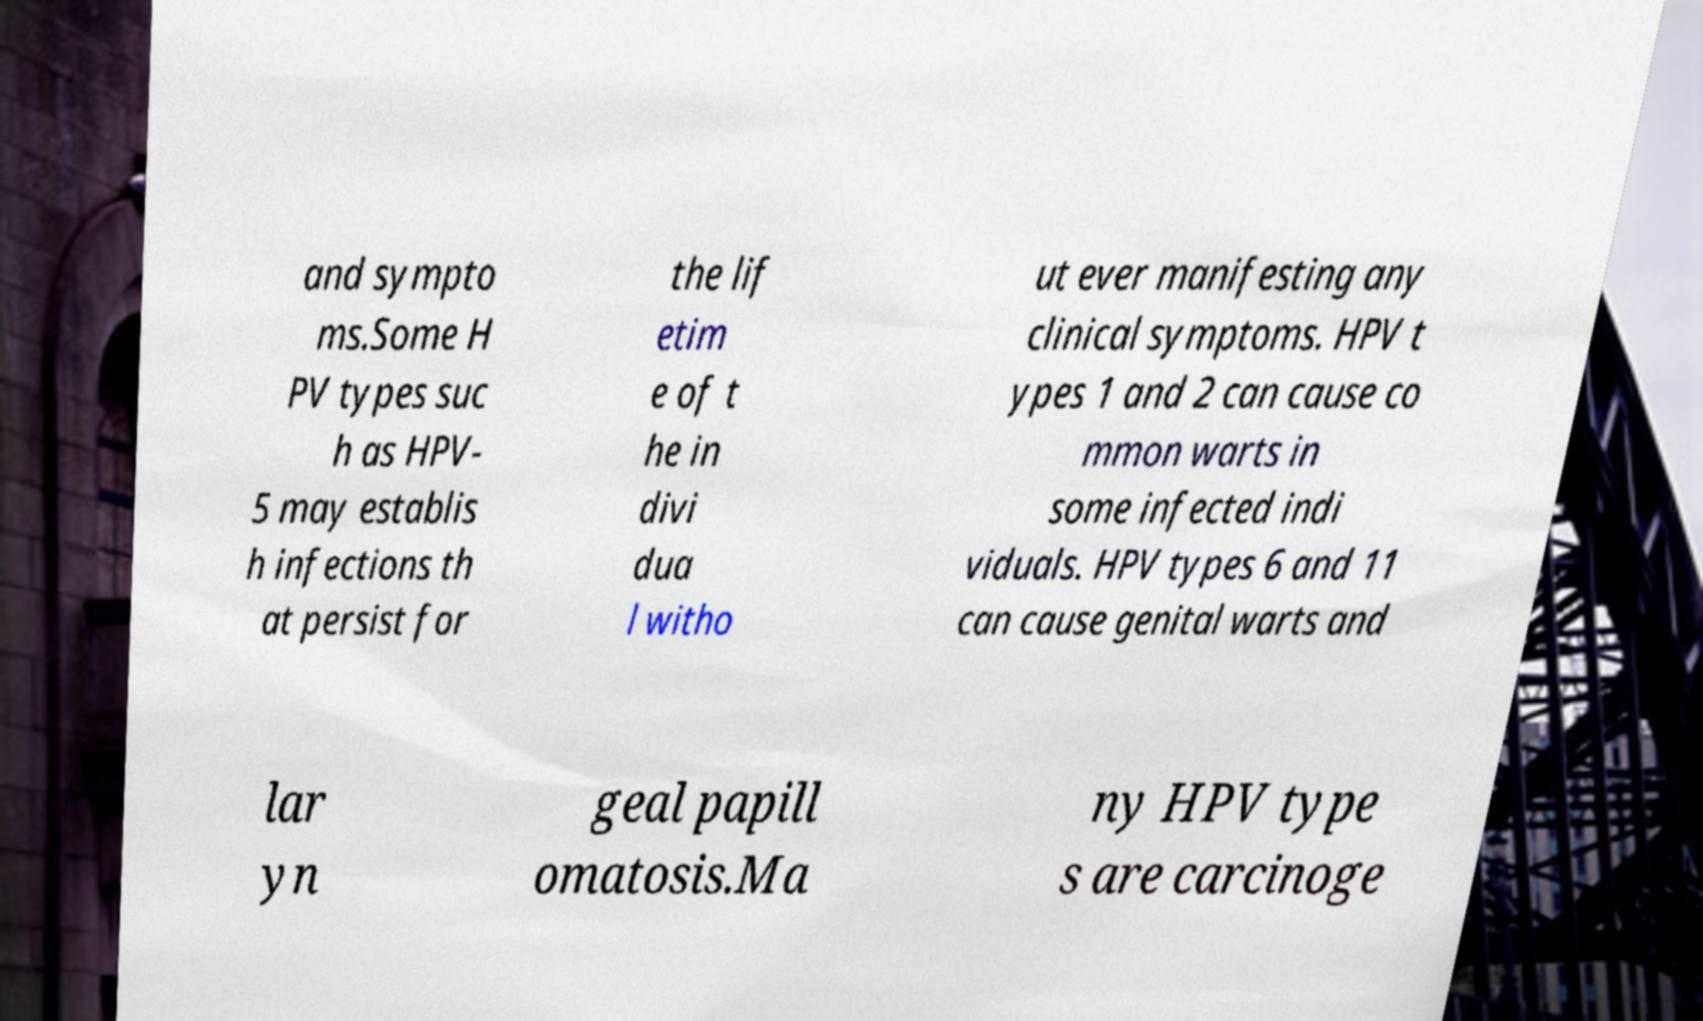For documentation purposes, I need the text within this image transcribed. Could you provide that? and sympto ms.Some H PV types suc h as HPV- 5 may establis h infections th at persist for the lif etim e of t he in divi dua l witho ut ever manifesting any clinical symptoms. HPV t ypes 1 and 2 can cause co mmon warts in some infected indi viduals. HPV types 6 and 11 can cause genital warts and lar yn geal papill omatosis.Ma ny HPV type s are carcinoge 